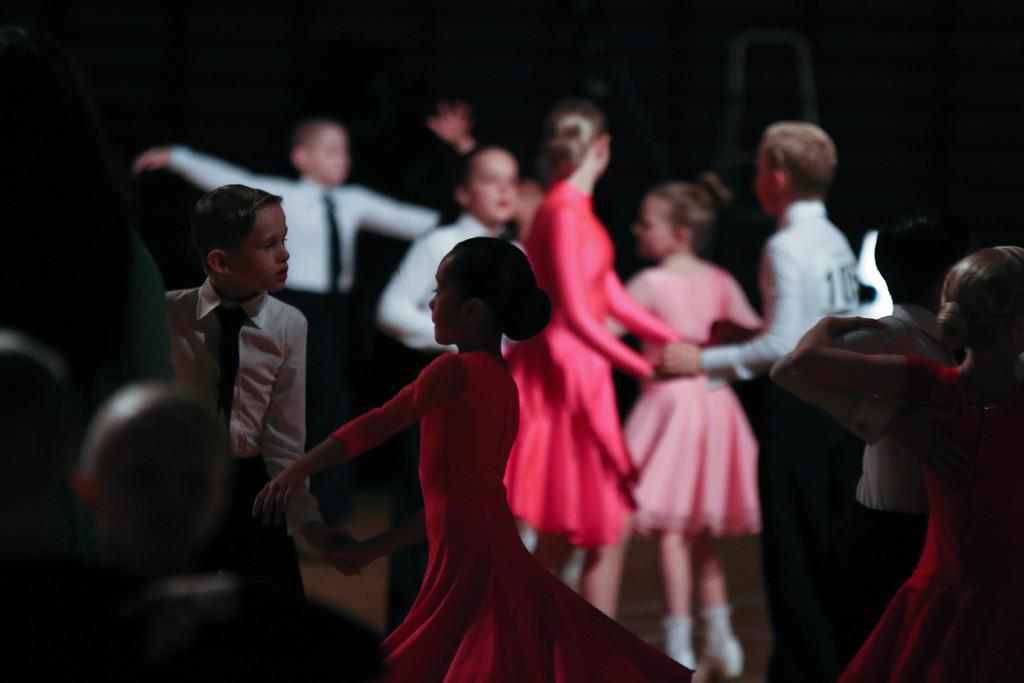How many people are in the image? There are multiple persons standing in the image. What can be observed about the background of the image? The background of the image is black. What type of amusement can be seen in the background of the image? There is no amusement present in the image, as the background is black and no amusement-related objects or activities are mentioned in the facts. 